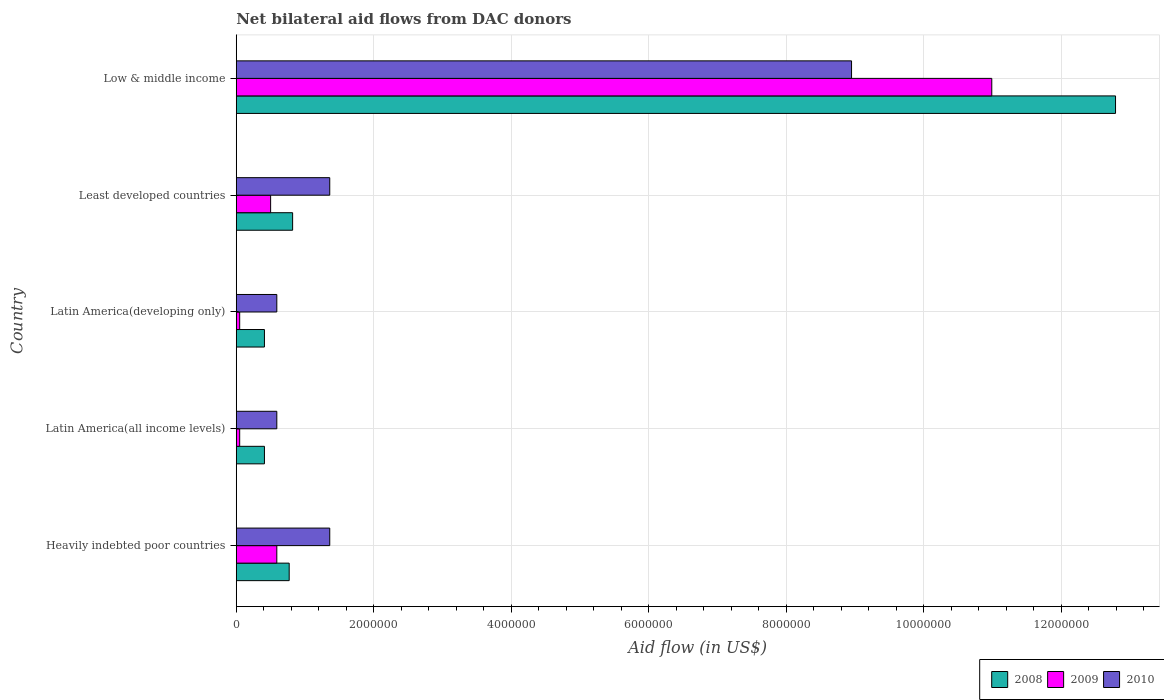How many different coloured bars are there?
Your answer should be compact. 3. What is the label of the 5th group of bars from the top?
Offer a terse response. Heavily indebted poor countries. In how many cases, is the number of bars for a given country not equal to the number of legend labels?
Give a very brief answer. 0. What is the net bilateral aid flow in 2010 in Latin America(developing only)?
Your response must be concise. 5.90e+05. Across all countries, what is the maximum net bilateral aid flow in 2008?
Offer a terse response. 1.28e+07. Across all countries, what is the minimum net bilateral aid flow in 2010?
Give a very brief answer. 5.90e+05. In which country was the net bilateral aid flow in 2008 maximum?
Ensure brevity in your answer.  Low & middle income. In which country was the net bilateral aid flow in 2008 minimum?
Your answer should be compact. Latin America(all income levels). What is the total net bilateral aid flow in 2009 in the graph?
Your response must be concise. 1.22e+07. What is the difference between the net bilateral aid flow in 2008 in Heavily indebted poor countries and that in Low & middle income?
Your answer should be very brief. -1.20e+07. What is the difference between the net bilateral aid flow in 2009 in Latin America(all income levels) and the net bilateral aid flow in 2010 in Least developed countries?
Give a very brief answer. -1.31e+06. What is the average net bilateral aid flow in 2009 per country?
Keep it short and to the point. 2.44e+06. What is the difference between the net bilateral aid flow in 2010 and net bilateral aid flow in 2009 in Heavily indebted poor countries?
Keep it short and to the point. 7.70e+05. What is the ratio of the net bilateral aid flow in 2008 in Least developed countries to that in Low & middle income?
Your answer should be compact. 0.06. What is the difference between the highest and the second highest net bilateral aid flow in 2008?
Your answer should be very brief. 1.20e+07. What is the difference between the highest and the lowest net bilateral aid flow in 2009?
Your response must be concise. 1.09e+07. Is the sum of the net bilateral aid flow in 2009 in Heavily indebted poor countries and Least developed countries greater than the maximum net bilateral aid flow in 2010 across all countries?
Give a very brief answer. No. What does the 2nd bar from the top in Latin America(developing only) represents?
Give a very brief answer. 2009. What does the 3rd bar from the bottom in Low & middle income represents?
Your answer should be compact. 2010. Is it the case that in every country, the sum of the net bilateral aid flow in 2009 and net bilateral aid flow in 2008 is greater than the net bilateral aid flow in 2010?
Your answer should be very brief. No. How many bars are there?
Your answer should be very brief. 15. What is the difference between two consecutive major ticks on the X-axis?
Your answer should be very brief. 2.00e+06. Does the graph contain grids?
Provide a succinct answer. Yes. Where does the legend appear in the graph?
Offer a very short reply. Bottom right. What is the title of the graph?
Offer a very short reply. Net bilateral aid flows from DAC donors. Does "1960" appear as one of the legend labels in the graph?
Give a very brief answer. No. What is the label or title of the X-axis?
Your response must be concise. Aid flow (in US$). What is the Aid flow (in US$) in 2008 in Heavily indebted poor countries?
Provide a short and direct response. 7.70e+05. What is the Aid flow (in US$) of 2009 in Heavily indebted poor countries?
Provide a short and direct response. 5.90e+05. What is the Aid flow (in US$) in 2010 in Heavily indebted poor countries?
Offer a very short reply. 1.36e+06. What is the Aid flow (in US$) in 2009 in Latin America(all income levels)?
Your answer should be very brief. 5.00e+04. What is the Aid flow (in US$) in 2010 in Latin America(all income levels)?
Offer a very short reply. 5.90e+05. What is the Aid flow (in US$) in 2009 in Latin America(developing only)?
Offer a very short reply. 5.00e+04. What is the Aid flow (in US$) in 2010 in Latin America(developing only)?
Ensure brevity in your answer.  5.90e+05. What is the Aid flow (in US$) of 2008 in Least developed countries?
Provide a short and direct response. 8.20e+05. What is the Aid flow (in US$) in 2010 in Least developed countries?
Make the answer very short. 1.36e+06. What is the Aid flow (in US$) in 2008 in Low & middle income?
Your answer should be compact. 1.28e+07. What is the Aid flow (in US$) in 2009 in Low & middle income?
Your response must be concise. 1.10e+07. What is the Aid flow (in US$) in 2010 in Low & middle income?
Make the answer very short. 8.95e+06. Across all countries, what is the maximum Aid flow (in US$) in 2008?
Keep it short and to the point. 1.28e+07. Across all countries, what is the maximum Aid flow (in US$) of 2009?
Offer a terse response. 1.10e+07. Across all countries, what is the maximum Aid flow (in US$) in 2010?
Provide a succinct answer. 8.95e+06. Across all countries, what is the minimum Aid flow (in US$) of 2010?
Make the answer very short. 5.90e+05. What is the total Aid flow (in US$) in 2008 in the graph?
Make the answer very short. 1.52e+07. What is the total Aid flow (in US$) of 2009 in the graph?
Ensure brevity in your answer.  1.22e+07. What is the total Aid flow (in US$) in 2010 in the graph?
Give a very brief answer. 1.28e+07. What is the difference between the Aid flow (in US$) of 2008 in Heavily indebted poor countries and that in Latin America(all income levels)?
Offer a terse response. 3.60e+05. What is the difference between the Aid flow (in US$) in 2009 in Heavily indebted poor countries and that in Latin America(all income levels)?
Provide a short and direct response. 5.40e+05. What is the difference between the Aid flow (in US$) in 2010 in Heavily indebted poor countries and that in Latin America(all income levels)?
Your answer should be very brief. 7.70e+05. What is the difference between the Aid flow (in US$) of 2009 in Heavily indebted poor countries and that in Latin America(developing only)?
Provide a succinct answer. 5.40e+05. What is the difference between the Aid flow (in US$) in 2010 in Heavily indebted poor countries and that in Latin America(developing only)?
Keep it short and to the point. 7.70e+05. What is the difference between the Aid flow (in US$) of 2008 in Heavily indebted poor countries and that in Least developed countries?
Keep it short and to the point. -5.00e+04. What is the difference between the Aid flow (in US$) of 2010 in Heavily indebted poor countries and that in Least developed countries?
Provide a short and direct response. 0. What is the difference between the Aid flow (in US$) in 2008 in Heavily indebted poor countries and that in Low & middle income?
Offer a terse response. -1.20e+07. What is the difference between the Aid flow (in US$) of 2009 in Heavily indebted poor countries and that in Low & middle income?
Offer a very short reply. -1.04e+07. What is the difference between the Aid flow (in US$) of 2010 in Heavily indebted poor countries and that in Low & middle income?
Offer a very short reply. -7.59e+06. What is the difference between the Aid flow (in US$) in 2009 in Latin America(all income levels) and that in Latin America(developing only)?
Provide a succinct answer. 0. What is the difference between the Aid flow (in US$) of 2008 in Latin America(all income levels) and that in Least developed countries?
Provide a succinct answer. -4.10e+05. What is the difference between the Aid flow (in US$) of 2009 in Latin America(all income levels) and that in Least developed countries?
Provide a succinct answer. -4.50e+05. What is the difference between the Aid flow (in US$) of 2010 in Latin America(all income levels) and that in Least developed countries?
Ensure brevity in your answer.  -7.70e+05. What is the difference between the Aid flow (in US$) of 2008 in Latin America(all income levels) and that in Low & middle income?
Provide a succinct answer. -1.24e+07. What is the difference between the Aid flow (in US$) in 2009 in Latin America(all income levels) and that in Low & middle income?
Offer a terse response. -1.09e+07. What is the difference between the Aid flow (in US$) of 2010 in Latin America(all income levels) and that in Low & middle income?
Make the answer very short. -8.36e+06. What is the difference between the Aid flow (in US$) in 2008 in Latin America(developing only) and that in Least developed countries?
Your answer should be very brief. -4.10e+05. What is the difference between the Aid flow (in US$) of 2009 in Latin America(developing only) and that in Least developed countries?
Give a very brief answer. -4.50e+05. What is the difference between the Aid flow (in US$) in 2010 in Latin America(developing only) and that in Least developed countries?
Your response must be concise. -7.70e+05. What is the difference between the Aid flow (in US$) of 2008 in Latin America(developing only) and that in Low & middle income?
Give a very brief answer. -1.24e+07. What is the difference between the Aid flow (in US$) of 2009 in Latin America(developing only) and that in Low & middle income?
Offer a terse response. -1.09e+07. What is the difference between the Aid flow (in US$) of 2010 in Latin America(developing only) and that in Low & middle income?
Offer a very short reply. -8.36e+06. What is the difference between the Aid flow (in US$) of 2008 in Least developed countries and that in Low & middle income?
Your answer should be compact. -1.20e+07. What is the difference between the Aid flow (in US$) of 2009 in Least developed countries and that in Low & middle income?
Provide a succinct answer. -1.05e+07. What is the difference between the Aid flow (in US$) in 2010 in Least developed countries and that in Low & middle income?
Your response must be concise. -7.59e+06. What is the difference between the Aid flow (in US$) of 2008 in Heavily indebted poor countries and the Aid flow (in US$) of 2009 in Latin America(all income levels)?
Your answer should be compact. 7.20e+05. What is the difference between the Aid flow (in US$) in 2009 in Heavily indebted poor countries and the Aid flow (in US$) in 2010 in Latin America(all income levels)?
Ensure brevity in your answer.  0. What is the difference between the Aid flow (in US$) in 2008 in Heavily indebted poor countries and the Aid flow (in US$) in 2009 in Latin America(developing only)?
Keep it short and to the point. 7.20e+05. What is the difference between the Aid flow (in US$) of 2008 in Heavily indebted poor countries and the Aid flow (in US$) of 2009 in Least developed countries?
Make the answer very short. 2.70e+05. What is the difference between the Aid flow (in US$) of 2008 in Heavily indebted poor countries and the Aid flow (in US$) of 2010 in Least developed countries?
Your response must be concise. -5.90e+05. What is the difference between the Aid flow (in US$) of 2009 in Heavily indebted poor countries and the Aid flow (in US$) of 2010 in Least developed countries?
Give a very brief answer. -7.70e+05. What is the difference between the Aid flow (in US$) of 2008 in Heavily indebted poor countries and the Aid flow (in US$) of 2009 in Low & middle income?
Your answer should be very brief. -1.02e+07. What is the difference between the Aid flow (in US$) in 2008 in Heavily indebted poor countries and the Aid flow (in US$) in 2010 in Low & middle income?
Your response must be concise. -8.18e+06. What is the difference between the Aid flow (in US$) of 2009 in Heavily indebted poor countries and the Aid flow (in US$) of 2010 in Low & middle income?
Offer a very short reply. -8.36e+06. What is the difference between the Aid flow (in US$) of 2008 in Latin America(all income levels) and the Aid flow (in US$) of 2009 in Latin America(developing only)?
Offer a very short reply. 3.60e+05. What is the difference between the Aid flow (in US$) of 2009 in Latin America(all income levels) and the Aid flow (in US$) of 2010 in Latin America(developing only)?
Offer a very short reply. -5.40e+05. What is the difference between the Aid flow (in US$) in 2008 in Latin America(all income levels) and the Aid flow (in US$) in 2010 in Least developed countries?
Give a very brief answer. -9.50e+05. What is the difference between the Aid flow (in US$) of 2009 in Latin America(all income levels) and the Aid flow (in US$) of 2010 in Least developed countries?
Your response must be concise. -1.31e+06. What is the difference between the Aid flow (in US$) in 2008 in Latin America(all income levels) and the Aid flow (in US$) in 2009 in Low & middle income?
Your response must be concise. -1.06e+07. What is the difference between the Aid flow (in US$) in 2008 in Latin America(all income levels) and the Aid flow (in US$) in 2010 in Low & middle income?
Your response must be concise. -8.54e+06. What is the difference between the Aid flow (in US$) of 2009 in Latin America(all income levels) and the Aid flow (in US$) of 2010 in Low & middle income?
Offer a very short reply. -8.90e+06. What is the difference between the Aid flow (in US$) of 2008 in Latin America(developing only) and the Aid flow (in US$) of 2010 in Least developed countries?
Your answer should be compact. -9.50e+05. What is the difference between the Aid flow (in US$) of 2009 in Latin America(developing only) and the Aid flow (in US$) of 2010 in Least developed countries?
Give a very brief answer. -1.31e+06. What is the difference between the Aid flow (in US$) of 2008 in Latin America(developing only) and the Aid flow (in US$) of 2009 in Low & middle income?
Ensure brevity in your answer.  -1.06e+07. What is the difference between the Aid flow (in US$) in 2008 in Latin America(developing only) and the Aid flow (in US$) in 2010 in Low & middle income?
Your answer should be compact. -8.54e+06. What is the difference between the Aid flow (in US$) in 2009 in Latin America(developing only) and the Aid flow (in US$) in 2010 in Low & middle income?
Offer a very short reply. -8.90e+06. What is the difference between the Aid flow (in US$) in 2008 in Least developed countries and the Aid flow (in US$) in 2009 in Low & middle income?
Provide a succinct answer. -1.02e+07. What is the difference between the Aid flow (in US$) of 2008 in Least developed countries and the Aid flow (in US$) of 2010 in Low & middle income?
Offer a very short reply. -8.13e+06. What is the difference between the Aid flow (in US$) of 2009 in Least developed countries and the Aid flow (in US$) of 2010 in Low & middle income?
Give a very brief answer. -8.45e+06. What is the average Aid flow (in US$) of 2008 per country?
Your answer should be very brief. 3.04e+06. What is the average Aid flow (in US$) of 2009 per country?
Offer a terse response. 2.44e+06. What is the average Aid flow (in US$) of 2010 per country?
Provide a short and direct response. 2.57e+06. What is the difference between the Aid flow (in US$) of 2008 and Aid flow (in US$) of 2009 in Heavily indebted poor countries?
Your answer should be very brief. 1.80e+05. What is the difference between the Aid flow (in US$) of 2008 and Aid flow (in US$) of 2010 in Heavily indebted poor countries?
Your answer should be compact. -5.90e+05. What is the difference between the Aid flow (in US$) in 2009 and Aid flow (in US$) in 2010 in Heavily indebted poor countries?
Give a very brief answer. -7.70e+05. What is the difference between the Aid flow (in US$) of 2008 and Aid flow (in US$) of 2009 in Latin America(all income levels)?
Provide a short and direct response. 3.60e+05. What is the difference between the Aid flow (in US$) of 2008 and Aid flow (in US$) of 2010 in Latin America(all income levels)?
Your answer should be very brief. -1.80e+05. What is the difference between the Aid flow (in US$) of 2009 and Aid flow (in US$) of 2010 in Latin America(all income levels)?
Your answer should be very brief. -5.40e+05. What is the difference between the Aid flow (in US$) in 2009 and Aid flow (in US$) in 2010 in Latin America(developing only)?
Give a very brief answer. -5.40e+05. What is the difference between the Aid flow (in US$) in 2008 and Aid flow (in US$) in 2009 in Least developed countries?
Your answer should be compact. 3.20e+05. What is the difference between the Aid flow (in US$) in 2008 and Aid flow (in US$) in 2010 in Least developed countries?
Provide a succinct answer. -5.40e+05. What is the difference between the Aid flow (in US$) in 2009 and Aid flow (in US$) in 2010 in Least developed countries?
Provide a short and direct response. -8.60e+05. What is the difference between the Aid flow (in US$) of 2008 and Aid flow (in US$) of 2009 in Low & middle income?
Your answer should be compact. 1.80e+06. What is the difference between the Aid flow (in US$) in 2008 and Aid flow (in US$) in 2010 in Low & middle income?
Make the answer very short. 3.84e+06. What is the difference between the Aid flow (in US$) in 2009 and Aid flow (in US$) in 2010 in Low & middle income?
Ensure brevity in your answer.  2.04e+06. What is the ratio of the Aid flow (in US$) of 2008 in Heavily indebted poor countries to that in Latin America(all income levels)?
Provide a succinct answer. 1.88. What is the ratio of the Aid flow (in US$) of 2009 in Heavily indebted poor countries to that in Latin America(all income levels)?
Your answer should be compact. 11.8. What is the ratio of the Aid flow (in US$) of 2010 in Heavily indebted poor countries to that in Latin America(all income levels)?
Offer a terse response. 2.31. What is the ratio of the Aid flow (in US$) in 2008 in Heavily indebted poor countries to that in Latin America(developing only)?
Offer a very short reply. 1.88. What is the ratio of the Aid flow (in US$) of 2009 in Heavily indebted poor countries to that in Latin America(developing only)?
Your answer should be very brief. 11.8. What is the ratio of the Aid flow (in US$) of 2010 in Heavily indebted poor countries to that in Latin America(developing only)?
Ensure brevity in your answer.  2.31. What is the ratio of the Aid flow (in US$) in 2008 in Heavily indebted poor countries to that in Least developed countries?
Make the answer very short. 0.94. What is the ratio of the Aid flow (in US$) in 2009 in Heavily indebted poor countries to that in Least developed countries?
Offer a terse response. 1.18. What is the ratio of the Aid flow (in US$) of 2010 in Heavily indebted poor countries to that in Least developed countries?
Your answer should be very brief. 1. What is the ratio of the Aid flow (in US$) of 2008 in Heavily indebted poor countries to that in Low & middle income?
Offer a very short reply. 0.06. What is the ratio of the Aid flow (in US$) of 2009 in Heavily indebted poor countries to that in Low & middle income?
Your response must be concise. 0.05. What is the ratio of the Aid flow (in US$) in 2010 in Heavily indebted poor countries to that in Low & middle income?
Provide a short and direct response. 0.15. What is the ratio of the Aid flow (in US$) in 2008 in Latin America(all income levels) to that in Latin America(developing only)?
Offer a very short reply. 1. What is the ratio of the Aid flow (in US$) in 2010 in Latin America(all income levels) to that in Latin America(developing only)?
Offer a terse response. 1. What is the ratio of the Aid flow (in US$) in 2010 in Latin America(all income levels) to that in Least developed countries?
Offer a terse response. 0.43. What is the ratio of the Aid flow (in US$) of 2008 in Latin America(all income levels) to that in Low & middle income?
Give a very brief answer. 0.03. What is the ratio of the Aid flow (in US$) of 2009 in Latin America(all income levels) to that in Low & middle income?
Your answer should be compact. 0. What is the ratio of the Aid flow (in US$) in 2010 in Latin America(all income levels) to that in Low & middle income?
Provide a short and direct response. 0.07. What is the ratio of the Aid flow (in US$) in 2010 in Latin America(developing only) to that in Least developed countries?
Your answer should be compact. 0.43. What is the ratio of the Aid flow (in US$) in 2008 in Latin America(developing only) to that in Low & middle income?
Offer a very short reply. 0.03. What is the ratio of the Aid flow (in US$) of 2009 in Latin America(developing only) to that in Low & middle income?
Offer a terse response. 0. What is the ratio of the Aid flow (in US$) in 2010 in Latin America(developing only) to that in Low & middle income?
Ensure brevity in your answer.  0.07. What is the ratio of the Aid flow (in US$) in 2008 in Least developed countries to that in Low & middle income?
Keep it short and to the point. 0.06. What is the ratio of the Aid flow (in US$) in 2009 in Least developed countries to that in Low & middle income?
Provide a short and direct response. 0.05. What is the ratio of the Aid flow (in US$) of 2010 in Least developed countries to that in Low & middle income?
Give a very brief answer. 0.15. What is the difference between the highest and the second highest Aid flow (in US$) of 2008?
Give a very brief answer. 1.20e+07. What is the difference between the highest and the second highest Aid flow (in US$) in 2009?
Keep it short and to the point. 1.04e+07. What is the difference between the highest and the second highest Aid flow (in US$) in 2010?
Offer a terse response. 7.59e+06. What is the difference between the highest and the lowest Aid flow (in US$) in 2008?
Make the answer very short. 1.24e+07. What is the difference between the highest and the lowest Aid flow (in US$) in 2009?
Offer a very short reply. 1.09e+07. What is the difference between the highest and the lowest Aid flow (in US$) of 2010?
Keep it short and to the point. 8.36e+06. 